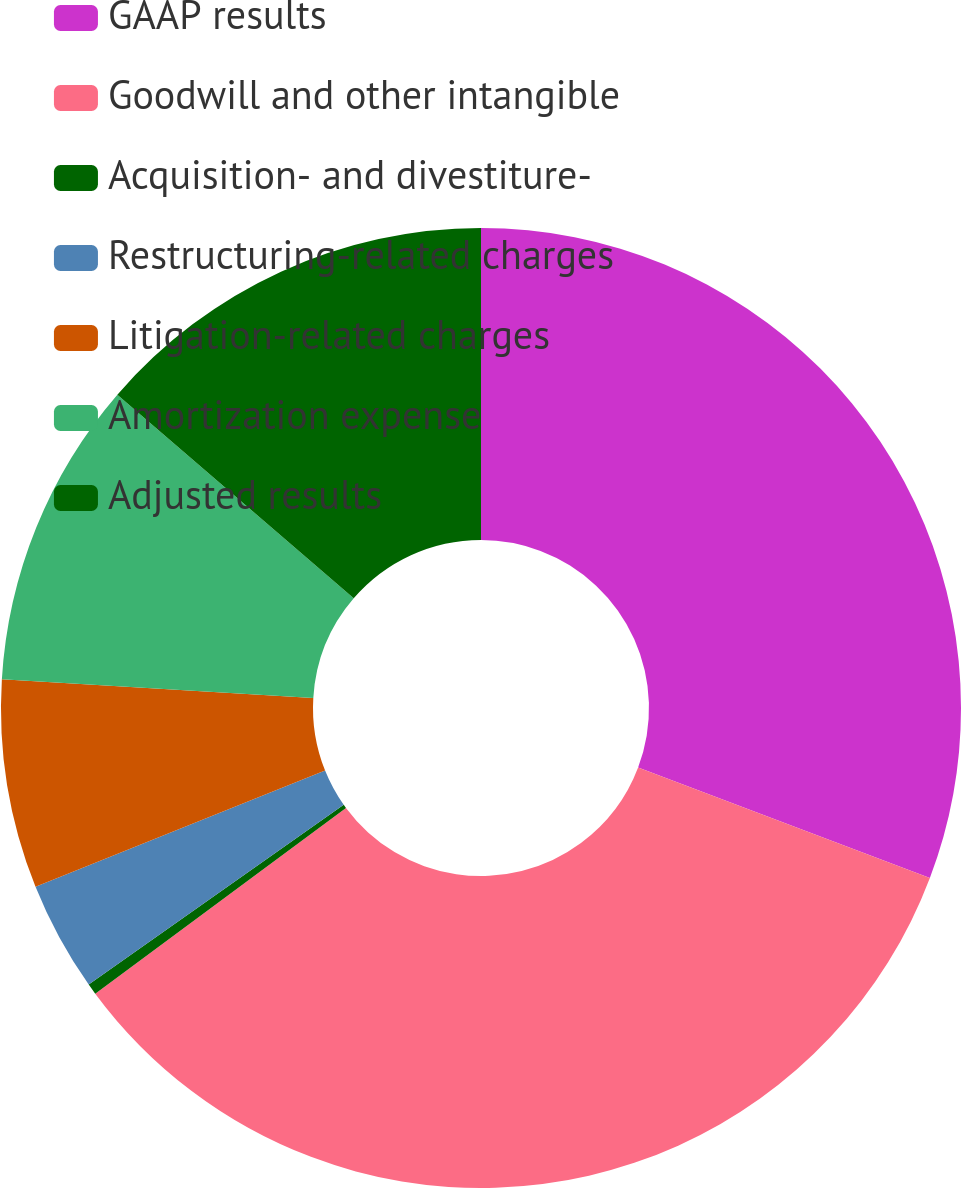<chart> <loc_0><loc_0><loc_500><loc_500><pie_chart><fcel>GAAP results<fcel>Goodwill and other intangible<fcel>Acquisition- and divestiture-<fcel>Restructuring-related charges<fcel>Litigation-related charges<fcel>Amortization expense<fcel>Adjusted results<nl><fcel>30.76%<fcel>34.09%<fcel>0.37%<fcel>3.7%<fcel>7.03%<fcel>10.36%<fcel>13.68%<nl></chart> 